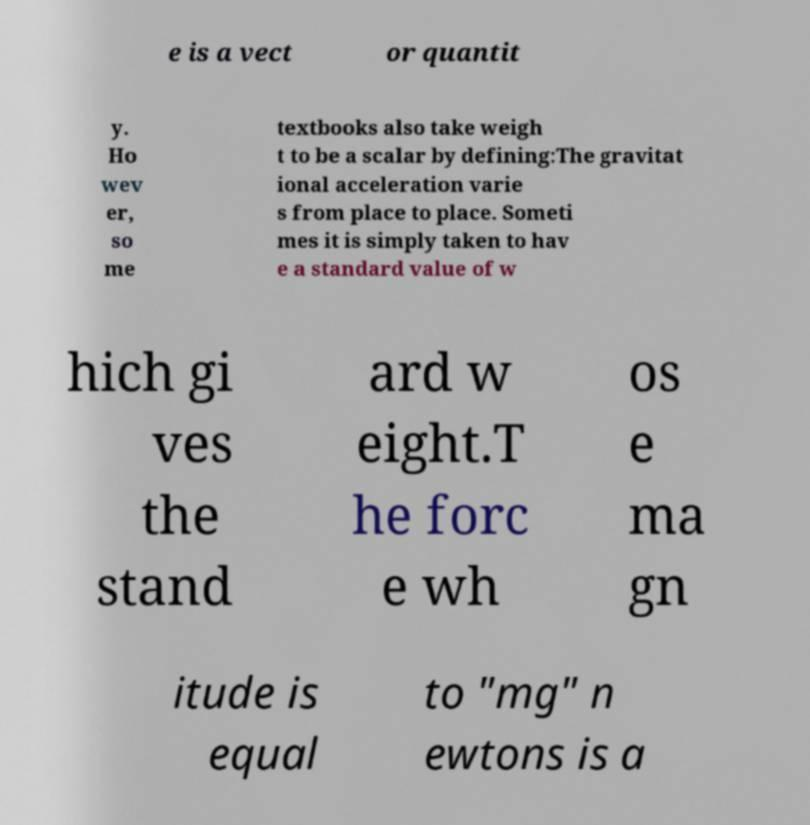Can you delve into the debate between weight being a vector or a scalar quantity? Weight is often considered a vector because it has direction - toward the center of the gravitational source. However, some contexts simplify weight as a scalar, focusing only on its magnitude without direction. The debate centers on the level of precision needed for particular applications and the conceptual clarity in educational settings. 